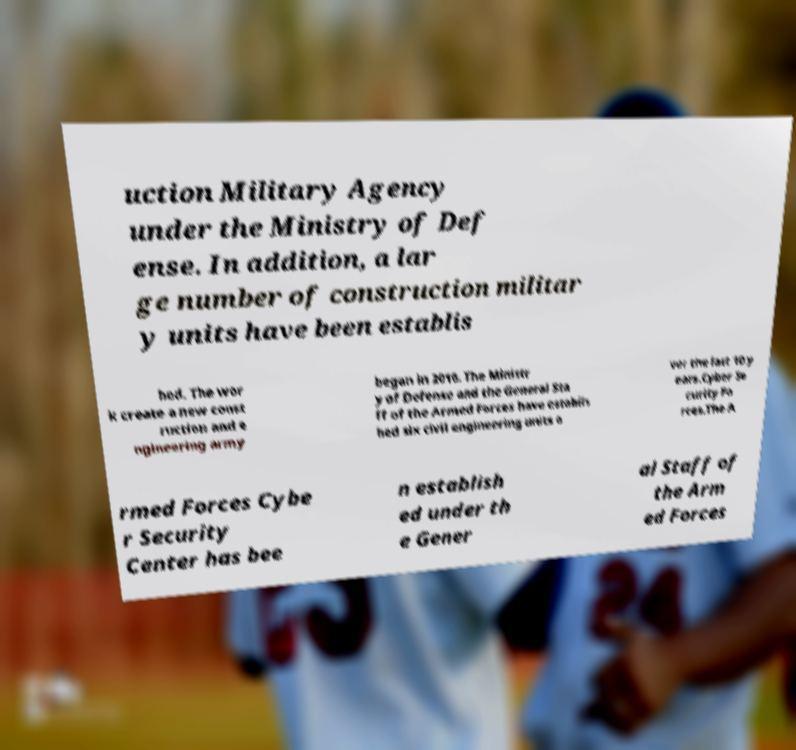There's text embedded in this image that I need extracted. Can you transcribe it verbatim? uction Military Agency under the Ministry of Def ense. In addition, a lar ge number of construction militar y units have been establis hed. The wor k create a new const ruction and e ngineering army began in 2010. The Ministr y of Defense and the General Sta ff of the Armed Forces have establis hed six civil engineering units o ver the last 10 y ears.Cyber Se curity Fo rces.The A rmed Forces Cybe r Security Center has bee n establish ed under th e Gener al Staff of the Arm ed Forces 